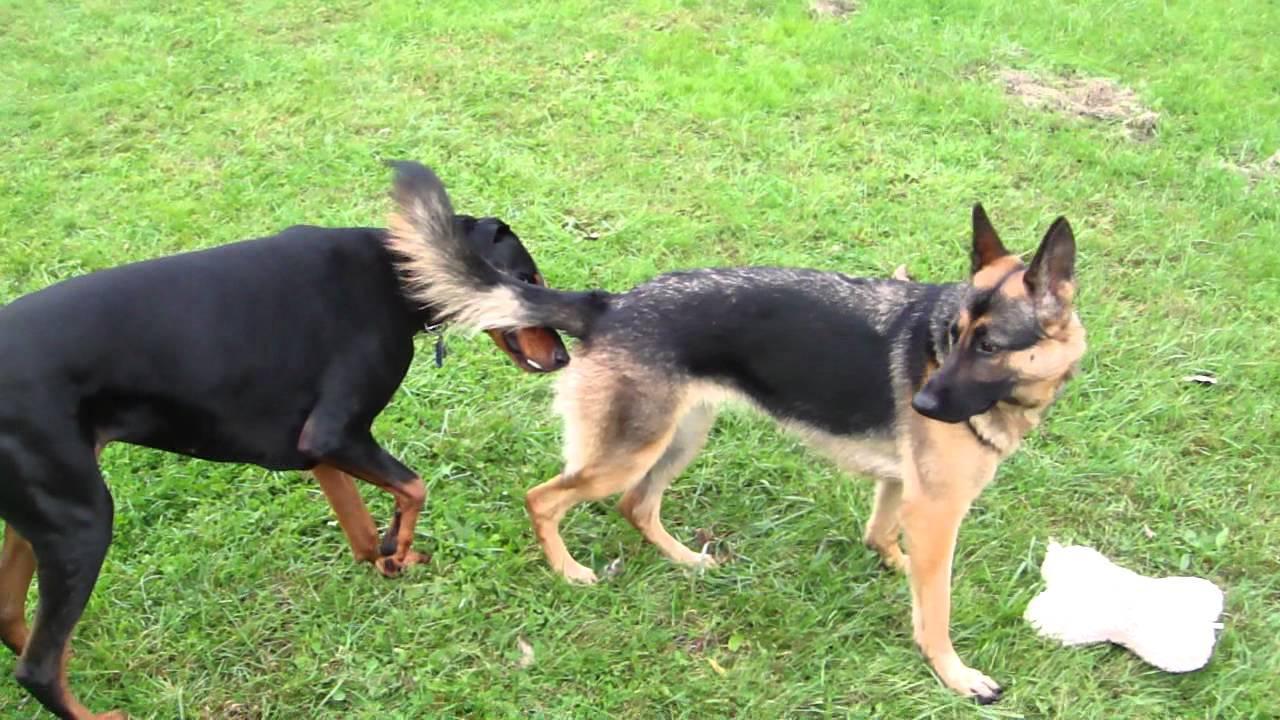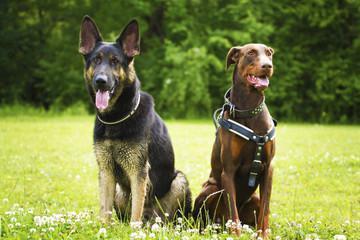The first image is the image on the left, the second image is the image on the right. Evaluate the accuracy of this statement regarding the images: "At least three dogs are dobermans with upright pointy ears, and no dogs are standing up with all four paws on the ground.". Is it true? Answer yes or no. No. The first image is the image on the left, the second image is the image on the right. Given the left and right images, does the statement "Two dogs are standing in the grass in the image on the left." hold true? Answer yes or no. Yes. 